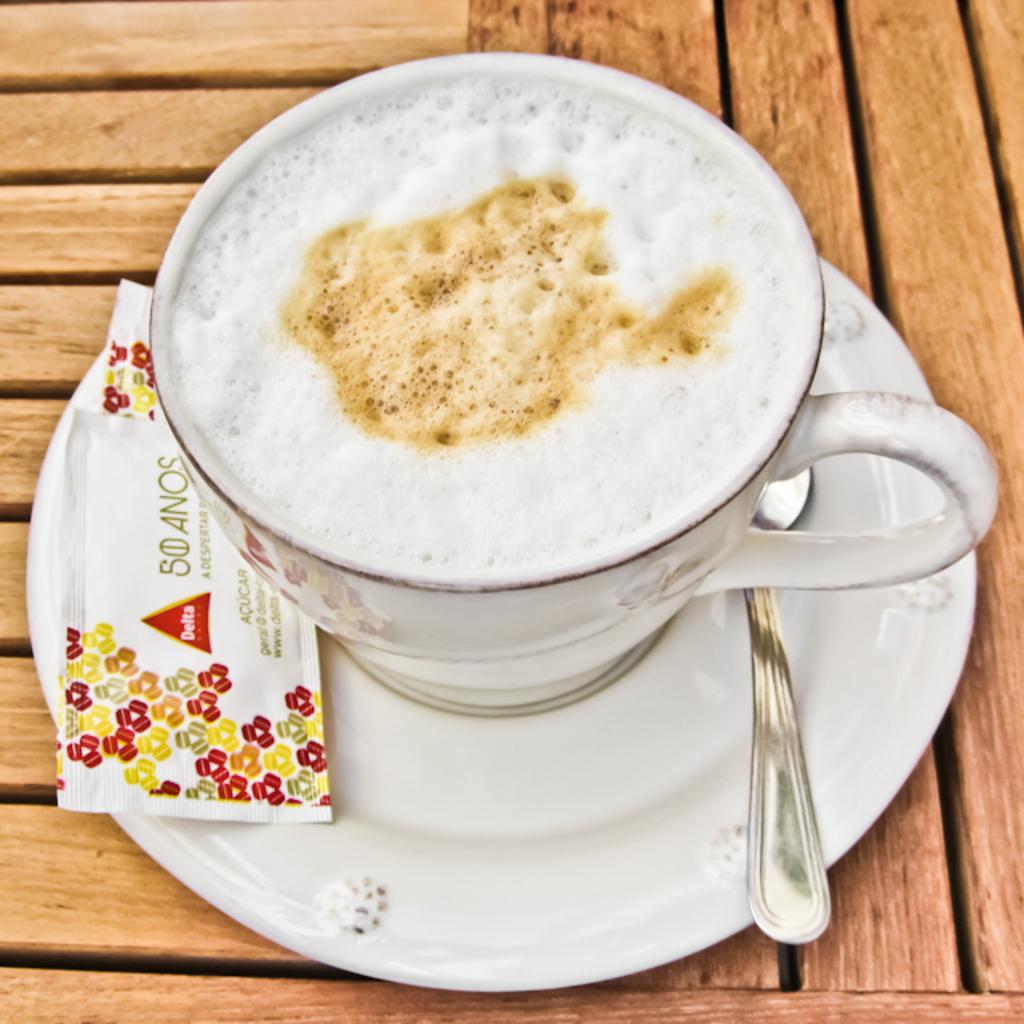Can you describe this image briefly? In this image we can see beverage in cup, spoon and saucer placed on the table. 